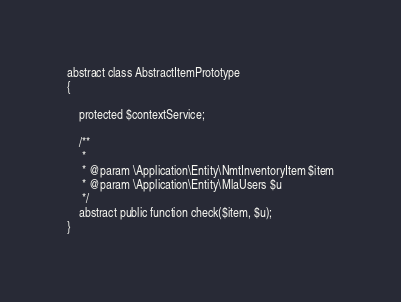<code> <loc_0><loc_0><loc_500><loc_500><_PHP_>abstract class AbstractItemPrototype
{

    protected $contextService;

    /**
     *
     * @param \Application\Entity\NmtInventoryItem $item
     * @param \Application\Entity\MlaUsers $u
     */
    abstract public function check($item, $u);
}</code> 